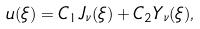Convert formula to latex. <formula><loc_0><loc_0><loc_500><loc_500>u ( \xi ) = C _ { 1 } J _ { \nu } ( \xi ) + C _ { 2 } Y _ { \nu } ( \xi ) ,</formula> 